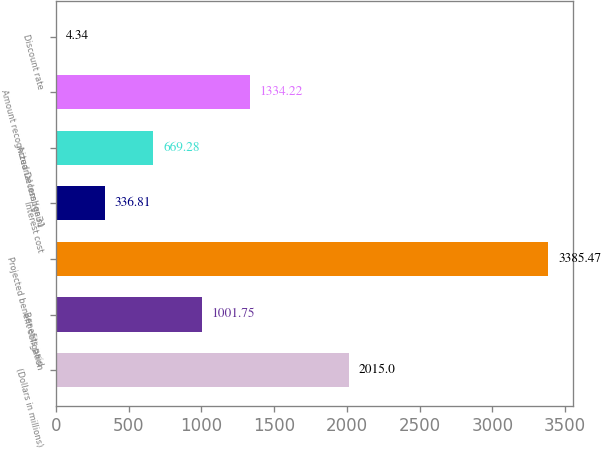Convert chart. <chart><loc_0><loc_0><loc_500><loc_500><bar_chart><fcel>(Dollars in millions)<fcel>Benefits paid<fcel>Projected benefit obligation<fcel>Interest cost<fcel>Actuarial loss (gain)<fcel>Amount recognized December 31<fcel>Discount rate<nl><fcel>2015<fcel>1001.75<fcel>3385.47<fcel>336.81<fcel>669.28<fcel>1334.22<fcel>4.34<nl></chart> 